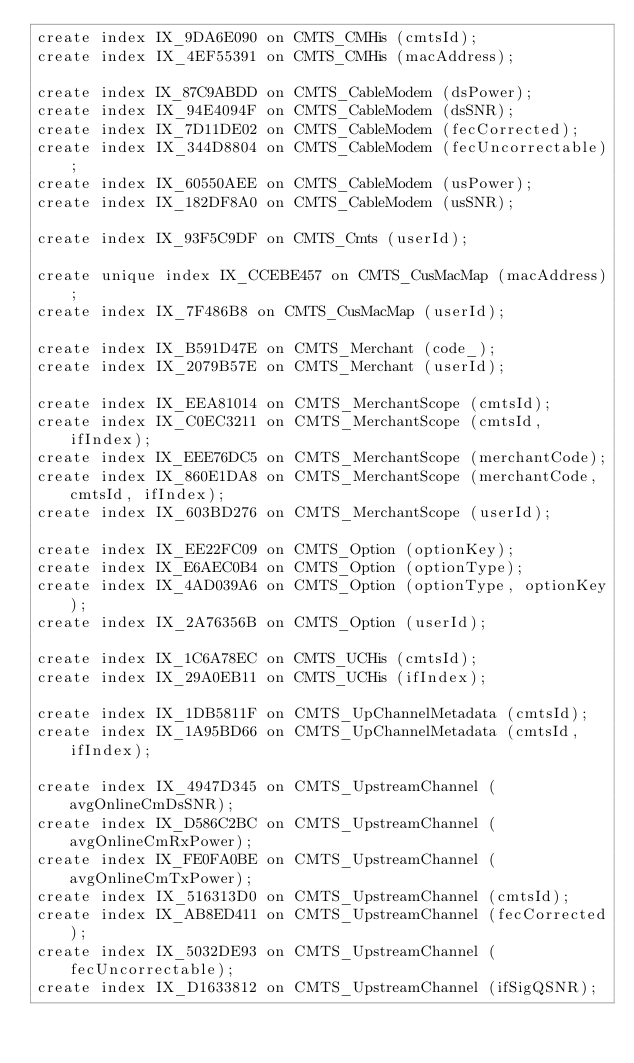Convert code to text. <code><loc_0><loc_0><loc_500><loc_500><_SQL_>create index IX_9DA6E090 on CMTS_CMHis (cmtsId);
create index IX_4EF55391 on CMTS_CMHis (macAddress);

create index IX_87C9ABDD on CMTS_CableModem (dsPower);
create index IX_94E4094F on CMTS_CableModem (dsSNR);
create index IX_7D11DE02 on CMTS_CableModem (fecCorrected);
create index IX_344D8804 on CMTS_CableModem (fecUncorrectable);
create index IX_60550AEE on CMTS_CableModem (usPower);
create index IX_182DF8A0 on CMTS_CableModem (usSNR);

create index IX_93F5C9DF on CMTS_Cmts (userId);

create unique index IX_CCEBE457 on CMTS_CusMacMap (macAddress);
create index IX_7F486B8 on CMTS_CusMacMap (userId);

create index IX_B591D47E on CMTS_Merchant (code_);
create index IX_2079B57E on CMTS_Merchant (userId);

create index IX_EEA81014 on CMTS_MerchantScope (cmtsId);
create index IX_C0EC3211 on CMTS_MerchantScope (cmtsId, ifIndex);
create index IX_EEE76DC5 on CMTS_MerchantScope (merchantCode);
create index IX_860E1DA8 on CMTS_MerchantScope (merchantCode, cmtsId, ifIndex);
create index IX_603BD276 on CMTS_MerchantScope (userId);

create index IX_EE22FC09 on CMTS_Option (optionKey);
create index IX_E6AEC0B4 on CMTS_Option (optionType);
create index IX_4AD039A6 on CMTS_Option (optionType, optionKey);
create index IX_2A76356B on CMTS_Option (userId);

create index IX_1C6A78EC on CMTS_UCHis (cmtsId);
create index IX_29A0EB11 on CMTS_UCHis (ifIndex);

create index IX_1DB5811F on CMTS_UpChannelMetadata (cmtsId);
create index IX_1A95BD66 on CMTS_UpChannelMetadata (cmtsId, ifIndex);

create index IX_4947D345 on CMTS_UpstreamChannel (avgOnlineCmDsSNR);
create index IX_D586C2BC on CMTS_UpstreamChannel (avgOnlineCmRxPower);
create index IX_FE0FA0BE on CMTS_UpstreamChannel (avgOnlineCmTxPower);
create index IX_516313D0 on CMTS_UpstreamChannel (cmtsId);
create index IX_AB8ED411 on CMTS_UpstreamChannel (fecCorrected);
create index IX_5032DE93 on CMTS_UpstreamChannel (fecUncorrectable);
create index IX_D1633812 on CMTS_UpstreamChannel (ifSigQSNR);</code> 